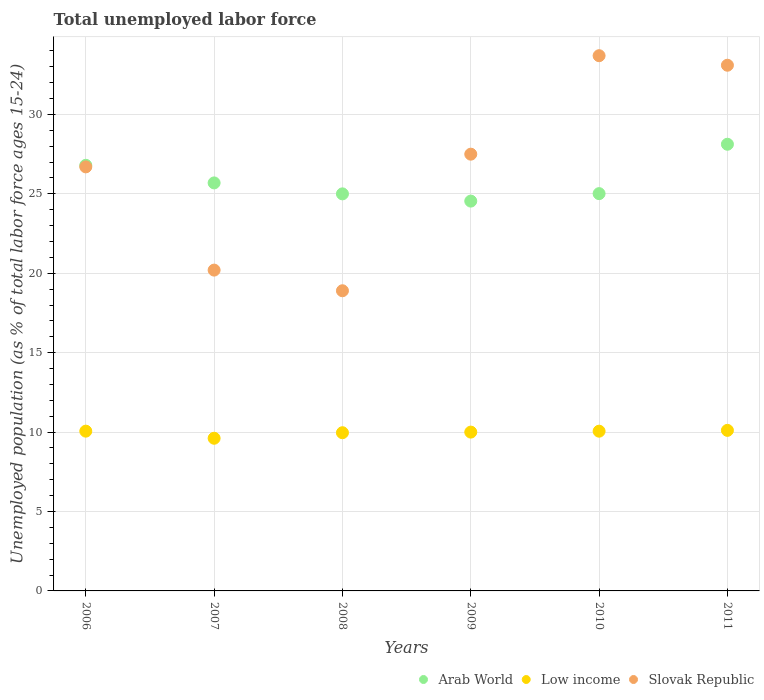How many different coloured dotlines are there?
Keep it short and to the point. 3. What is the percentage of unemployed population in in Arab World in 2006?
Provide a short and direct response. 26.8. Across all years, what is the maximum percentage of unemployed population in in Low income?
Ensure brevity in your answer.  10.11. Across all years, what is the minimum percentage of unemployed population in in Arab World?
Keep it short and to the point. 24.55. In which year was the percentage of unemployed population in in Arab World minimum?
Provide a succinct answer. 2009. What is the total percentage of unemployed population in in Arab World in the graph?
Ensure brevity in your answer.  155.18. What is the difference between the percentage of unemployed population in in Low income in 2007 and that in 2011?
Your response must be concise. -0.5. What is the difference between the percentage of unemployed population in in Arab World in 2008 and the percentage of unemployed population in in Slovak Republic in 2009?
Your answer should be very brief. -2.5. What is the average percentage of unemployed population in in Slovak Republic per year?
Your response must be concise. 26.68. In the year 2006, what is the difference between the percentage of unemployed population in in Slovak Republic and percentage of unemployed population in in Arab World?
Ensure brevity in your answer.  -0.1. In how many years, is the percentage of unemployed population in in Arab World greater than 25 %?
Make the answer very short. 5. What is the ratio of the percentage of unemployed population in in Low income in 2009 to that in 2010?
Your response must be concise. 0.99. Is the percentage of unemployed population in in Arab World in 2006 less than that in 2009?
Give a very brief answer. No. Is the difference between the percentage of unemployed population in in Slovak Republic in 2007 and 2009 greater than the difference between the percentage of unemployed population in in Arab World in 2007 and 2009?
Give a very brief answer. No. What is the difference between the highest and the second highest percentage of unemployed population in in Arab World?
Your answer should be compact. 1.33. What is the difference between the highest and the lowest percentage of unemployed population in in Slovak Republic?
Provide a short and direct response. 14.8. In how many years, is the percentage of unemployed population in in Slovak Republic greater than the average percentage of unemployed population in in Slovak Republic taken over all years?
Provide a short and direct response. 4. Is it the case that in every year, the sum of the percentage of unemployed population in in Slovak Republic and percentage of unemployed population in in Low income  is greater than the percentage of unemployed population in in Arab World?
Your response must be concise. Yes. Is the percentage of unemployed population in in Arab World strictly greater than the percentage of unemployed population in in Slovak Republic over the years?
Provide a succinct answer. No. What is the difference between two consecutive major ticks on the Y-axis?
Provide a short and direct response. 5. Does the graph contain grids?
Your answer should be compact. Yes. Where does the legend appear in the graph?
Your answer should be very brief. Bottom right. How many legend labels are there?
Make the answer very short. 3. What is the title of the graph?
Ensure brevity in your answer.  Total unemployed labor force. Does "Caribbean small states" appear as one of the legend labels in the graph?
Your answer should be very brief. No. What is the label or title of the X-axis?
Keep it short and to the point. Years. What is the label or title of the Y-axis?
Provide a short and direct response. Unemployed population (as % of total labor force ages 15-24). What is the Unemployed population (as % of total labor force ages 15-24) of Arab World in 2006?
Provide a short and direct response. 26.8. What is the Unemployed population (as % of total labor force ages 15-24) in Low income in 2006?
Ensure brevity in your answer.  10.06. What is the Unemployed population (as % of total labor force ages 15-24) in Slovak Republic in 2006?
Your answer should be very brief. 26.7. What is the Unemployed population (as % of total labor force ages 15-24) in Arab World in 2007?
Give a very brief answer. 25.69. What is the Unemployed population (as % of total labor force ages 15-24) in Low income in 2007?
Make the answer very short. 9.61. What is the Unemployed population (as % of total labor force ages 15-24) in Slovak Republic in 2007?
Offer a very short reply. 20.2. What is the Unemployed population (as % of total labor force ages 15-24) of Arab World in 2008?
Make the answer very short. 25. What is the Unemployed population (as % of total labor force ages 15-24) of Low income in 2008?
Your response must be concise. 9.96. What is the Unemployed population (as % of total labor force ages 15-24) in Slovak Republic in 2008?
Ensure brevity in your answer.  18.9. What is the Unemployed population (as % of total labor force ages 15-24) in Arab World in 2009?
Your answer should be very brief. 24.55. What is the Unemployed population (as % of total labor force ages 15-24) of Low income in 2009?
Your answer should be very brief. 10. What is the Unemployed population (as % of total labor force ages 15-24) of Arab World in 2010?
Provide a short and direct response. 25.02. What is the Unemployed population (as % of total labor force ages 15-24) in Low income in 2010?
Your response must be concise. 10.06. What is the Unemployed population (as % of total labor force ages 15-24) in Slovak Republic in 2010?
Make the answer very short. 33.7. What is the Unemployed population (as % of total labor force ages 15-24) of Arab World in 2011?
Provide a succinct answer. 28.12. What is the Unemployed population (as % of total labor force ages 15-24) of Low income in 2011?
Offer a very short reply. 10.11. What is the Unemployed population (as % of total labor force ages 15-24) in Slovak Republic in 2011?
Offer a very short reply. 33.1. Across all years, what is the maximum Unemployed population (as % of total labor force ages 15-24) of Arab World?
Your answer should be very brief. 28.12. Across all years, what is the maximum Unemployed population (as % of total labor force ages 15-24) in Low income?
Your response must be concise. 10.11. Across all years, what is the maximum Unemployed population (as % of total labor force ages 15-24) in Slovak Republic?
Make the answer very short. 33.7. Across all years, what is the minimum Unemployed population (as % of total labor force ages 15-24) of Arab World?
Give a very brief answer. 24.55. Across all years, what is the minimum Unemployed population (as % of total labor force ages 15-24) of Low income?
Offer a terse response. 9.61. Across all years, what is the minimum Unemployed population (as % of total labor force ages 15-24) in Slovak Republic?
Offer a very short reply. 18.9. What is the total Unemployed population (as % of total labor force ages 15-24) of Arab World in the graph?
Your answer should be compact. 155.18. What is the total Unemployed population (as % of total labor force ages 15-24) in Low income in the graph?
Offer a terse response. 59.8. What is the total Unemployed population (as % of total labor force ages 15-24) of Slovak Republic in the graph?
Your answer should be compact. 160.1. What is the difference between the Unemployed population (as % of total labor force ages 15-24) in Arab World in 2006 and that in 2007?
Offer a terse response. 1.11. What is the difference between the Unemployed population (as % of total labor force ages 15-24) of Low income in 2006 and that in 2007?
Offer a terse response. 0.45. What is the difference between the Unemployed population (as % of total labor force ages 15-24) of Slovak Republic in 2006 and that in 2007?
Provide a short and direct response. 6.5. What is the difference between the Unemployed population (as % of total labor force ages 15-24) in Arab World in 2006 and that in 2008?
Your answer should be very brief. 1.8. What is the difference between the Unemployed population (as % of total labor force ages 15-24) in Low income in 2006 and that in 2008?
Provide a succinct answer. 0.1. What is the difference between the Unemployed population (as % of total labor force ages 15-24) of Slovak Republic in 2006 and that in 2008?
Your answer should be compact. 7.8. What is the difference between the Unemployed population (as % of total labor force ages 15-24) of Arab World in 2006 and that in 2009?
Offer a very short reply. 2.25. What is the difference between the Unemployed population (as % of total labor force ages 15-24) in Low income in 2006 and that in 2009?
Your answer should be very brief. 0.06. What is the difference between the Unemployed population (as % of total labor force ages 15-24) in Arab World in 2006 and that in 2010?
Offer a very short reply. 1.78. What is the difference between the Unemployed population (as % of total labor force ages 15-24) in Low income in 2006 and that in 2010?
Provide a short and direct response. 0. What is the difference between the Unemployed population (as % of total labor force ages 15-24) in Arab World in 2006 and that in 2011?
Make the answer very short. -1.33. What is the difference between the Unemployed population (as % of total labor force ages 15-24) of Low income in 2006 and that in 2011?
Give a very brief answer. -0.05. What is the difference between the Unemployed population (as % of total labor force ages 15-24) of Arab World in 2007 and that in 2008?
Make the answer very short. 0.69. What is the difference between the Unemployed population (as % of total labor force ages 15-24) in Low income in 2007 and that in 2008?
Your answer should be compact. -0.35. What is the difference between the Unemployed population (as % of total labor force ages 15-24) in Slovak Republic in 2007 and that in 2008?
Give a very brief answer. 1.3. What is the difference between the Unemployed population (as % of total labor force ages 15-24) of Arab World in 2007 and that in 2009?
Provide a short and direct response. 1.15. What is the difference between the Unemployed population (as % of total labor force ages 15-24) in Low income in 2007 and that in 2009?
Ensure brevity in your answer.  -0.39. What is the difference between the Unemployed population (as % of total labor force ages 15-24) of Slovak Republic in 2007 and that in 2009?
Give a very brief answer. -7.3. What is the difference between the Unemployed population (as % of total labor force ages 15-24) of Arab World in 2007 and that in 2010?
Give a very brief answer. 0.67. What is the difference between the Unemployed population (as % of total labor force ages 15-24) in Low income in 2007 and that in 2010?
Give a very brief answer. -0.44. What is the difference between the Unemployed population (as % of total labor force ages 15-24) of Slovak Republic in 2007 and that in 2010?
Keep it short and to the point. -13.5. What is the difference between the Unemployed population (as % of total labor force ages 15-24) of Arab World in 2007 and that in 2011?
Provide a succinct answer. -2.43. What is the difference between the Unemployed population (as % of total labor force ages 15-24) in Low income in 2007 and that in 2011?
Make the answer very short. -0.5. What is the difference between the Unemployed population (as % of total labor force ages 15-24) of Arab World in 2008 and that in 2009?
Your answer should be very brief. 0.46. What is the difference between the Unemployed population (as % of total labor force ages 15-24) of Low income in 2008 and that in 2009?
Give a very brief answer. -0.04. What is the difference between the Unemployed population (as % of total labor force ages 15-24) in Slovak Republic in 2008 and that in 2009?
Provide a succinct answer. -8.6. What is the difference between the Unemployed population (as % of total labor force ages 15-24) in Arab World in 2008 and that in 2010?
Your answer should be compact. -0.01. What is the difference between the Unemployed population (as % of total labor force ages 15-24) in Low income in 2008 and that in 2010?
Provide a succinct answer. -0.1. What is the difference between the Unemployed population (as % of total labor force ages 15-24) in Slovak Republic in 2008 and that in 2010?
Make the answer very short. -14.8. What is the difference between the Unemployed population (as % of total labor force ages 15-24) in Arab World in 2008 and that in 2011?
Your response must be concise. -3.12. What is the difference between the Unemployed population (as % of total labor force ages 15-24) in Low income in 2008 and that in 2011?
Provide a short and direct response. -0.15. What is the difference between the Unemployed population (as % of total labor force ages 15-24) in Arab World in 2009 and that in 2010?
Provide a short and direct response. -0.47. What is the difference between the Unemployed population (as % of total labor force ages 15-24) of Low income in 2009 and that in 2010?
Provide a succinct answer. -0.06. What is the difference between the Unemployed population (as % of total labor force ages 15-24) in Slovak Republic in 2009 and that in 2010?
Give a very brief answer. -6.2. What is the difference between the Unemployed population (as % of total labor force ages 15-24) of Arab World in 2009 and that in 2011?
Your answer should be compact. -3.58. What is the difference between the Unemployed population (as % of total labor force ages 15-24) in Low income in 2009 and that in 2011?
Provide a succinct answer. -0.11. What is the difference between the Unemployed population (as % of total labor force ages 15-24) of Arab World in 2010 and that in 2011?
Provide a short and direct response. -3.11. What is the difference between the Unemployed population (as % of total labor force ages 15-24) of Low income in 2010 and that in 2011?
Provide a short and direct response. -0.05. What is the difference between the Unemployed population (as % of total labor force ages 15-24) of Slovak Republic in 2010 and that in 2011?
Offer a terse response. 0.6. What is the difference between the Unemployed population (as % of total labor force ages 15-24) in Arab World in 2006 and the Unemployed population (as % of total labor force ages 15-24) in Low income in 2007?
Give a very brief answer. 17.19. What is the difference between the Unemployed population (as % of total labor force ages 15-24) in Arab World in 2006 and the Unemployed population (as % of total labor force ages 15-24) in Slovak Republic in 2007?
Keep it short and to the point. 6.6. What is the difference between the Unemployed population (as % of total labor force ages 15-24) in Low income in 2006 and the Unemployed population (as % of total labor force ages 15-24) in Slovak Republic in 2007?
Offer a terse response. -10.14. What is the difference between the Unemployed population (as % of total labor force ages 15-24) in Arab World in 2006 and the Unemployed population (as % of total labor force ages 15-24) in Low income in 2008?
Your response must be concise. 16.84. What is the difference between the Unemployed population (as % of total labor force ages 15-24) in Arab World in 2006 and the Unemployed population (as % of total labor force ages 15-24) in Slovak Republic in 2008?
Ensure brevity in your answer.  7.9. What is the difference between the Unemployed population (as % of total labor force ages 15-24) of Low income in 2006 and the Unemployed population (as % of total labor force ages 15-24) of Slovak Republic in 2008?
Ensure brevity in your answer.  -8.84. What is the difference between the Unemployed population (as % of total labor force ages 15-24) of Arab World in 2006 and the Unemployed population (as % of total labor force ages 15-24) of Low income in 2009?
Offer a terse response. 16.8. What is the difference between the Unemployed population (as % of total labor force ages 15-24) of Arab World in 2006 and the Unemployed population (as % of total labor force ages 15-24) of Slovak Republic in 2009?
Provide a succinct answer. -0.7. What is the difference between the Unemployed population (as % of total labor force ages 15-24) in Low income in 2006 and the Unemployed population (as % of total labor force ages 15-24) in Slovak Republic in 2009?
Offer a terse response. -17.44. What is the difference between the Unemployed population (as % of total labor force ages 15-24) of Arab World in 2006 and the Unemployed population (as % of total labor force ages 15-24) of Low income in 2010?
Your answer should be compact. 16.74. What is the difference between the Unemployed population (as % of total labor force ages 15-24) in Arab World in 2006 and the Unemployed population (as % of total labor force ages 15-24) in Slovak Republic in 2010?
Ensure brevity in your answer.  -6.9. What is the difference between the Unemployed population (as % of total labor force ages 15-24) in Low income in 2006 and the Unemployed population (as % of total labor force ages 15-24) in Slovak Republic in 2010?
Your response must be concise. -23.64. What is the difference between the Unemployed population (as % of total labor force ages 15-24) in Arab World in 2006 and the Unemployed population (as % of total labor force ages 15-24) in Low income in 2011?
Your answer should be very brief. 16.69. What is the difference between the Unemployed population (as % of total labor force ages 15-24) of Arab World in 2006 and the Unemployed population (as % of total labor force ages 15-24) of Slovak Republic in 2011?
Provide a short and direct response. -6.3. What is the difference between the Unemployed population (as % of total labor force ages 15-24) of Low income in 2006 and the Unemployed population (as % of total labor force ages 15-24) of Slovak Republic in 2011?
Offer a terse response. -23.04. What is the difference between the Unemployed population (as % of total labor force ages 15-24) in Arab World in 2007 and the Unemployed population (as % of total labor force ages 15-24) in Low income in 2008?
Offer a very short reply. 15.73. What is the difference between the Unemployed population (as % of total labor force ages 15-24) in Arab World in 2007 and the Unemployed population (as % of total labor force ages 15-24) in Slovak Republic in 2008?
Ensure brevity in your answer.  6.79. What is the difference between the Unemployed population (as % of total labor force ages 15-24) of Low income in 2007 and the Unemployed population (as % of total labor force ages 15-24) of Slovak Republic in 2008?
Your answer should be compact. -9.29. What is the difference between the Unemployed population (as % of total labor force ages 15-24) of Arab World in 2007 and the Unemployed population (as % of total labor force ages 15-24) of Low income in 2009?
Your answer should be very brief. 15.69. What is the difference between the Unemployed population (as % of total labor force ages 15-24) of Arab World in 2007 and the Unemployed population (as % of total labor force ages 15-24) of Slovak Republic in 2009?
Ensure brevity in your answer.  -1.81. What is the difference between the Unemployed population (as % of total labor force ages 15-24) in Low income in 2007 and the Unemployed population (as % of total labor force ages 15-24) in Slovak Republic in 2009?
Offer a very short reply. -17.89. What is the difference between the Unemployed population (as % of total labor force ages 15-24) of Arab World in 2007 and the Unemployed population (as % of total labor force ages 15-24) of Low income in 2010?
Your answer should be compact. 15.63. What is the difference between the Unemployed population (as % of total labor force ages 15-24) of Arab World in 2007 and the Unemployed population (as % of total labor force ages 15-24) of Slovak Republic in 2010?
Your answer should be very brief. -8.01. What is the difference between the Unemployed population (as % of total labor force ages 15-24) of Low income in 2007 and the Unemployed population (as % of total labor force ages 15-24) of Slovak Republic in 2010?
Provide a succinct answer. -24.09. What is the difference between the Unemployed population (as % of total labor force ages 15-24) of Arab World in 2007 and the Unemployed population (as % of total labor force ages 15-24) of Low income in 2011?
Your response must be concise. 15.58. What is the difference between the Unemployed population (as % of total labor force ages 15-24) of Arab World in 2007 and the Unemployed population (as % of total labor force ages 15-24) of Slovak Republic in 2011?
Offer a terse response. -7.41. What is the difference between the Unemployed population (as % of total labor force ages 15-24) in Low income in 2007 and the Unemployed population (as % of total labor force ages 15-24) in Slovak Republic in 2011?
Make the answer very short. -23.49. What is the difference between the Unemployed population (as % of total labor force ages 15-24) of Arab World in 2008 and the Unemployed population (as % of total labor force ages 15-24) of Low income in 2009?
Your answer should be very brief. 15. What is the difference between the Unemployed population (as % of total labor force ages 15-24) of Arab World in 2008 and the Unemployed population (as % of total labor force ages 15-24) of Slovak Republic in 2009?
Offer a very short reply. -2.5. What is the difference between the Unemployed population (as % of total labor force ages 15-24) of Low income in 2008 and the Unemployed population (as % of total labor force ages 15-24) of Slovak Republic in 2009?
Your answer should be very brief. -17.54. What is the difference between the Unemployed population (as % of total labor force ages 15-24) of Arab World in 2008 and the Unemployed population (as % of total labor force ages 15-24) of Low income in 2010?
Provide a short and direct response. 14.94. What is the difference between the Unemployed population (as % of total labor force ages 15-24) of Arab World in 2008 and the Unemployed population (as % of total labor force ages 15-24) of Slovak Republic in 2010?
Your answer should be very brief. -8.7. What is the difference between the Unemployed population (as % of total labor force ages 15-24) of Low income in 2008 and the Unemployed population (as % of total labor force ages 15-24) of Slovak Republic in 2010?
Your response must be concise. -23.74. What is the difference between the Unemployed population (as % of total labor force ages 15-24) in Arab World in 2008 and the Unemployed population (as % of total labor force ages 15-24) in Low income in 2011?
Give a very brief answer. 14.89. What is the difference between the Unemployed population (as % of total labor force ages 15-24) in Arab World in 2008 and the Unemployed population (as % of total labor force ages 15-24) in Slovak Republic in 2011?
Offer a terse response. -8.1. What is the difference between the Unemployed population (as % of total labor force ages 15-24) of Low income in 2008 and the Unemployed population (as % of total labor force ages 15-24) of Slovak Republic in 2011?
Your response must be concise. -23.14. What is the difference between the Unemployed population (as % of total labor force ages 15-24) in Arab World in 2009 and the Unemployed population (as % of total labor force ages 15-24) in Low income in 2010?
Your response must be concise. 14.49. What is the difference between the Unemployed population (as % of total labor force ages 15-24) in Arab World in 2009 and the Unemployed population (as % of total labor force ages 15-24) in Slovak Republic in 2010?
Your answer should be very brief. -9.15. What is the difference between the Unemployed population (as % of total labor force ages 15-24) of Low income in 2009 and the Unemployed population (as % of total labor force ages 15-24) of Slovak Republic in 2010?
Your answer should be very brief. -23.7. What is the difference between the Unemployed population (as % of total labor force ages 15-24) in Arab World in 2009 and the Unemployed population (as % of total labor force ages 15-24) in Low income in 2011?
Make the answer very short. 14.44. What is the difference between the Unemployed population (as % of total labor force ages 15-24) in Arab World in 2009 and the Unemployed population (as % of total labor force ages 15-24) in Slovak Republic in 2011?
Keep it short and to the point. -8.55. What is the difference between the Unemployed population (as % of total labor force ages 15-24) of Low income in 2009 and the Unemployed population (as % of total labor force ages 15-24) of Slovak Republic in 2011?
Provide a succinct answer. -23.1. What is the difference between the Unemployed population (as % of total labor force ages 15-24) of Arab World in 2010 and the Unemployed population (as % of total labor force ages 15-24) of Low income in 2011?
Give a very brief answer. 14.91. What is the difference between the Unemployed population (as % of total labor force ages 15-24) of Arab World in 2010 and the Unemployed population (as % of total labor force ages 15-24) of Slovak Republic in 2011?
Provide a short and direct response. -8.08. What is the difference between the Unemployed population (as % of total labor force ages 15-24) in Low income in 2010 and the Unemployed population (as % of total labor force ages 15-24) in Slovak Republic in 2011?
Your response must be concise. -23.04. What is the average Unemployed population (as % of total labor force ages 15-24) of Arab World per year?
Offer a terse response. 25.86. What is the average Unemployed population (as % of total labor force ages 15-24) in Low income per year?
Provide a short and direct response. 9.97. What is the average Unemployed population (as % of total labor force ages 15-24) in Slovak Republic per year?
Keep it short and to the point. 26.68. In the year 2006, what is the difference between the Unemployed population (as % of total labor force ages 15-24) of Arab World and Unemployed population (as % of total labor force ages 15-24) of Low income?
Provide a succinct answer. 16.74. In the year 2006, what is the difference between the Unemployed population (as % of total labor force ages 15-24) of Arab World and Unemployed population (as % of total labor force ages 15-24) of Slovak Republic?
Your answer should be compact. 0.1. In the year 2006, what is the difference between the Unemployed population (as % of total labor force ages 15-24) in Low income and Unemployed population (as % of total labor force ages 15-24) in Slovak Republic?
Your response must be concise. -16.64. In the year 2007, what is the difference between the Unemployed population (as % of total labor force ages 15-24) of Arab World and Unemployed population (as % of total labor force ages 15-24) of Low income?
Your answer should be compact. 16.08. In the year 2007, what is the difference between the Unemployed population (as % of total labor force ages 15-24) in Arab World and Unemployed population (as % of total labor force ages 15-24) in Slovak Republic?
Keep it short and to the point. 5.49. In the year 2007, what is the difference between the Unemployed population (as % of total labor force ages 15-24) in Low income and Unemployed population (as % of total labor force ages 15-24) in Slovak Republic?
Provide a succinct answer. -10.59. In the year 2008, what is the difference between the Unemployed population (as % of total labor force ages 15-24) in Arab World and Unemployed population (as % of total labor force ages 15-24) in Low income?
Your answer should be compact. 15.04. In the year 2008, what is the difference between the Unemployed population (as % of total labor force ages 15-24) of Arab World and Unemployed population (as % of total labor force ages 15-24) of Slovak Republic?
Your answer should be compact. 6.1. In the year 2008, what is the difference between the Unemployed population (as % of total labor force ages 15-24) of Low income and Unemployed population (as % of total labor force ages 15-24) of Slovak Republic?
Your response must be concise. -8.94. In the year 2009, what is the difference between the Unemployed population (as % of total labor force ages 15-24) in Arab World and Unemployed population (as % of total labor force ages 15-24) in Low income?
Your answer should be compact. 14.55. In the year 2009, what is the difference between the Unemployed population (as % of total labor force ages 15-24) in Arab World and Unemployed population (as % of total labor force ages 15-24) in Slovak Republic?
Keep it short and to the point. -2.96. In the year 2009, what is the difference between the Unemployed population (as % of total labor force ages 15-24) of Low income and Unemployed population (as % of total labor force ages 15-24) of Slovak Republic?
Give a very brief answer. -17.5. In the year 2010, what is the difference between the Unemployed population (as % of total labor force ages 15-24) in Arab World and Unemployed population (as % of total labor force ages 15-24) in Low income?
Your response must be concise. 14.96. In the year 2010, what is the difference between the Unemployed population (as % of total labor force ages 15-24) of Arab World and Unemployed population (as % of total labor force ages 15-24) of Slovak Republic?
Your answer should be very brief. -8.68. In the year 2010, what is the difference between the Unemployed population (as % of total labor force ages 15-24) of Low income and Unemployed population (as % of total labor force ages 15-24) of Slovak Republic?
Offer a very short reply. -23.64. In the year 2011, what is the difference between the Unemployed population (as % of total labor force ages 15-24) in Arab World and Unemployed population (as % of total labor force ages 15-24) in Low income?
Make the answer very short. 18.02. In the year 2011, what is the difference between the Unemployed population (as % of total labor force ages 15-24) of Arab World and Unemployed population (as % of total labor force ages 15-24) of Slovak Republic?
Make the answer very short. -4.98. In the year 2011, what is the difference between the Unemployed population (as % of total labor force ages 15-24) in Low income and Unemployed population (as % of total labor force ages 15-24) in Slovak Republic?
Provide a short and direct response. -22.99. What is the ratio of the Unemployed population (as % of total labor force ages 15-24) in Arab World in 2006 to that in 2007?
Provide a succinct answer. 1.04. What is the ratio of the Unemployed population (as % of total labor force ages 15-24) in Low income in 2006 to that in 2007?
Your answer should be very brief. 1.05. What is the ratio of the Unemployed population (as % of total labor force ages 15-24) of Slovak Republic in 2006 to that in 2007?
Provide a short and direct response. 1.32. What is the ratio of the Unemployed population (as % of total labor force ages 15-24) of Arab World in 2006 to that in 2008?
Give a very brief answer. 1.07. What is the ratio of the Unemployed population (as % of total labor force ages 15-24) in Low income in 2006 to that in 2008?
Ensure brevity in your answer.  1.01. What is the ratio of the Unemployed population (as % of total labor force ages 15-24) in Slovak Republic in 2006 to that in 2008?
Make the answer very short. 1.41. What is the ratio of the Unemployed population (as % of total labor force ages 15-24) in Arab World in 2006 to that in 2009?
Your response must be concise. 1.09. What is the ratio of the Unemployed population (as % of total labor force ages 15-24) in Low income in 2006 to that in 2009?
Give a very brief answer. 1.01. What is the ratio of the Unemployed population (as % of total labor force ages 15-24) in Slovak Republic in 2006 to that in 2009?
Offer a terse response. 0.97. What is the ratio of the Unemployed population (as % of total labor force ages 15-24) in Arab World in 2006 to that in 2010?
Make the answer very short. 1.07. What is the ratio of the Unemployed population (as % of total labor force ages 15-24) of Slovak Republic in 2006 to that in 2010?
Offer a very short reply. 0.79. What is the ratio of the Unemployed population (as % of total labor force ages 15-24) in Arab World in 2006 to that in 2011?
Your answer should be compact. 0.95. What is the ratio of the Unemployed population (as % of total labor force ages 15-24) in Low income in 2006 to that in 2011?
Offer a terse response. 1. What is the ratio of the Unemployed population (as % of total labor force ages 15-24) in Slovak Republic in 2006 to that in 2011?
Ensure brevity in your answer.  0.81. What is the ratio of the Unemployed population (as % of total labor force ages 15-24) in Arab World in 2007 to that in 2008?
Provide a short and direct response. 1.03. What is the ratio of the Unemployed population (as % of total labor force ages 15-24) of Low income in 2007 to that in 2008?
Your answer should be very brief. 0.97. What is the ratio of the Unemployed population (as % of total labor force ages 15-24) in Slovak Republic in 2007 to that in 2008?
Make the answer very short. 1.07. What is the ratio of the Unemployed population (as % of total labor force ages 15-24) of Arab World in 2007 to that in 2009?
Ensure brevity in your answer.  1.05. What is the ratio of the Unemployed population (as % of total labor force ages 15-24) of Low income in 2007 to that in 2009?
Your answer should be compact. 0.96. What is the ratio of the Unemployed population (as % of total labor force ages 15-24) in Slovak Republic in 2007 to that in 2009?
Your answer should be very brief. 0.73. What is the ratio of the Unemployed population (as % of total labor force ages 15-24) in Low income in 2007 to that in 2010?
Your answer should be compact. 0.96. What is the ratio of the Unemployed population (as % of total labor force ages 15-24) in Slovak Republic in 2007 to that in 2010?
Keep it short and to the point. 0.6. What is the ratio of the Unemployed population (as % of total labor force ages 15-24) of Arab World in 2007 to that in 2011?
Ensure brevity in your answer.  0.91. What is the ratio of the Unemployed population (as % of total labor force ages 15-24) in Low income in 2007 to that in 2011?
Make the answer very short. 0.95. What is the ratio of the Unemployed population (as % of total labor force ages 15-24) of Slovak Republic in 2007 to that in 2011?
Offer a very short reply. 0.61. What is the ratio of the Unemployed population (as % of total labor force ages 15-24) in Arab World in 2008 to that in 2009?
Your response must be concise. 1.02. What is the ratio of the Unemployed population (as % of total labor force ages 15-24) in Low income in 2008 to that in 2009?
Offer a terse response. 1. What is the ratio of the Unemployed population (as % of total labor force ages 15-24) of Slovak Republic in 2008 to that in 2009?
Your answer should be compact. 0.69. What is the ratio of the Unemployed population (as % of total labor force ages 15-24) of Low income in 2008 to that in 2010?
Provide a short and direct response. 0.99. What is the ratio of the Unemployed population (as % of total labor force ages 15-24) in Slovak Republic in 2008 to that in 2010?
Your answer should be very brief. 0.56. What is the ratio of the Unemployed population (as % of total labor force ages 15-24) in Slovak Republic in 2008 to that in 2011?
Keep it short and to the point. 0.57. What is the ratio of the Unemployed population (as % of total labor force ages 15-24) in Arab World in 2009 to that in 2010?
Make the answer very short. 0.98. What is the ratio of the Unemployed population (as % of total labor force ages 15-24) of Low income in 2009 to that in 2010?
Your answer should be very brief. 0.99. What is the ratio of the Unemployed population (as % of total labor force ages 15-24) in Slovak Republic in 2009 to that in 2010?
Your answer should be very brief. 0.82. What is the ratio of the Unemployed population (as % of total labor force ages 15-24) of Arab World in 2009 to that in 2011?
Your response must be concise. 0.87. What is the ratio of the Unemployed population (as % of total labor force ages 15-24) of Low income in 2009 to that in 2011?
Ensure brevity in your answer.  0.99. What is the ratio of the Unemployed population (as % of total labor force ages 15-24) in Slovak Republic in 2009 to that in 2011?
Make the answer very short. 0.83. What is the ratio of the Unemployed population (as % of total labor force ages 15-24) of Arab World in 2010 to that in 2011?
Make the answer very short. 0.89. What is the ratio of the Unemployed population (as % of total labor force ages 15-24) of Slovak Republic in 2010 to that in 2011?
Make the answer very short. 1.02. What is the difference between the highest and the second highest Unemployed population (as % of total labor force ages 15-24) of Arab World?
Ensure brevity in your answer.  1.33. What is the difference between the highest and the second highest Unemployed population (as % of total labor force ages 15-24) in Low income?
Provide a short and direct response. 0.05. What is the difference between the highest and the second highest Unemployed population (as % of total labor force ages 15-24) in Slovak Republic?
Your answer should be compact. 0.6. What is the difference between the highest and the lowest Unemployed population (as % of total labor force ages 15-24) of Arab World?
Your answer should be compact. 3.58. What is the difference between the highest and the lowest Unemployed population (as % of total labor force ages 15-24) in Low income?
Offer a very short reply. 0.5. What is the difference between the highest and the lowest Unemployed population (as % of total labor force ages 15-24) of Slovak Republic?
Ensure brevity in your answer.  14.8. 